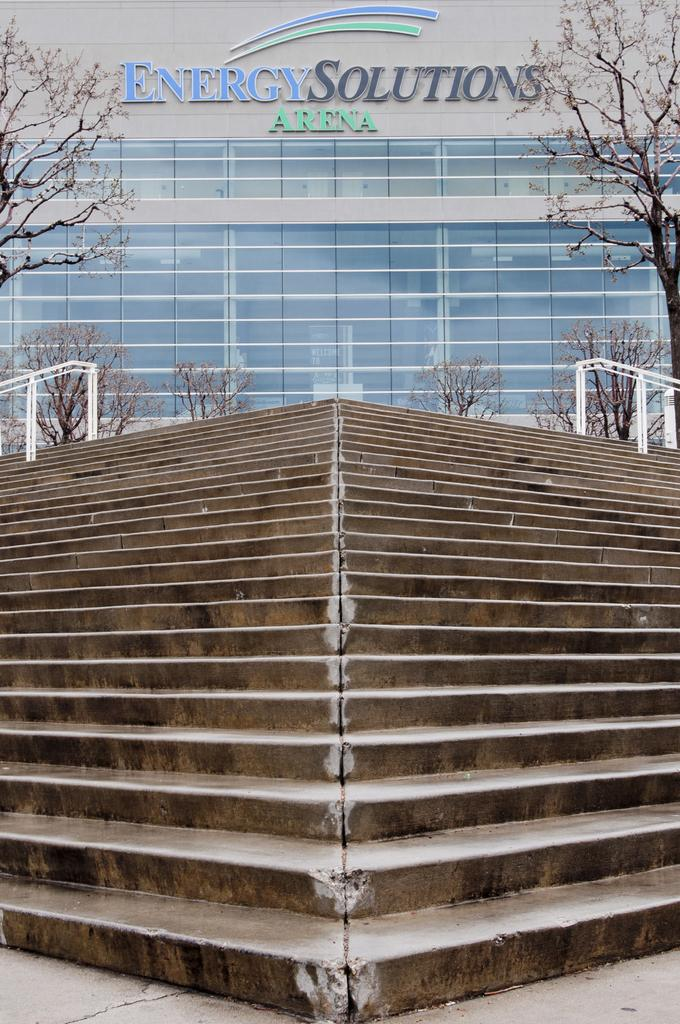What type of structure is visible in the image? There is a building in the image. Can you describe any text or signage on the building? Yes, there is text written on the building. What type of natural elements can be seen in the image? There are trees in the image. What architectural feature is present in front of the building? There are stairs in front of the building. What decision does the farmer make in the image? There is no farmer present in the image, so no decision can be made by a farmer. 